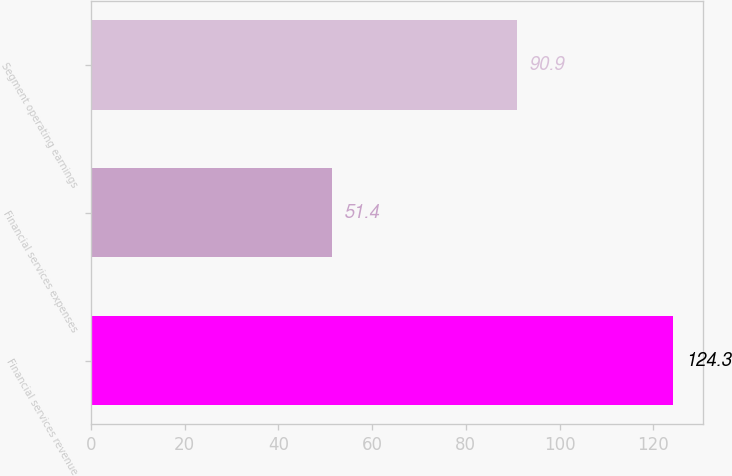Convert chart to OTSL. <chart><loc_0><loc_0><loc_500><loc_500><bar_chart><fcel>Financial services revenue<fcel>Financial services expenses<fcel>Segment operating earnings<nl><fcel>124.3<fcel>51.4<fcel>90.9<nl></chart> 